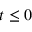<formula> <loc_0><loc_0><loc_500><loc_500>t \leq 0</formula> 